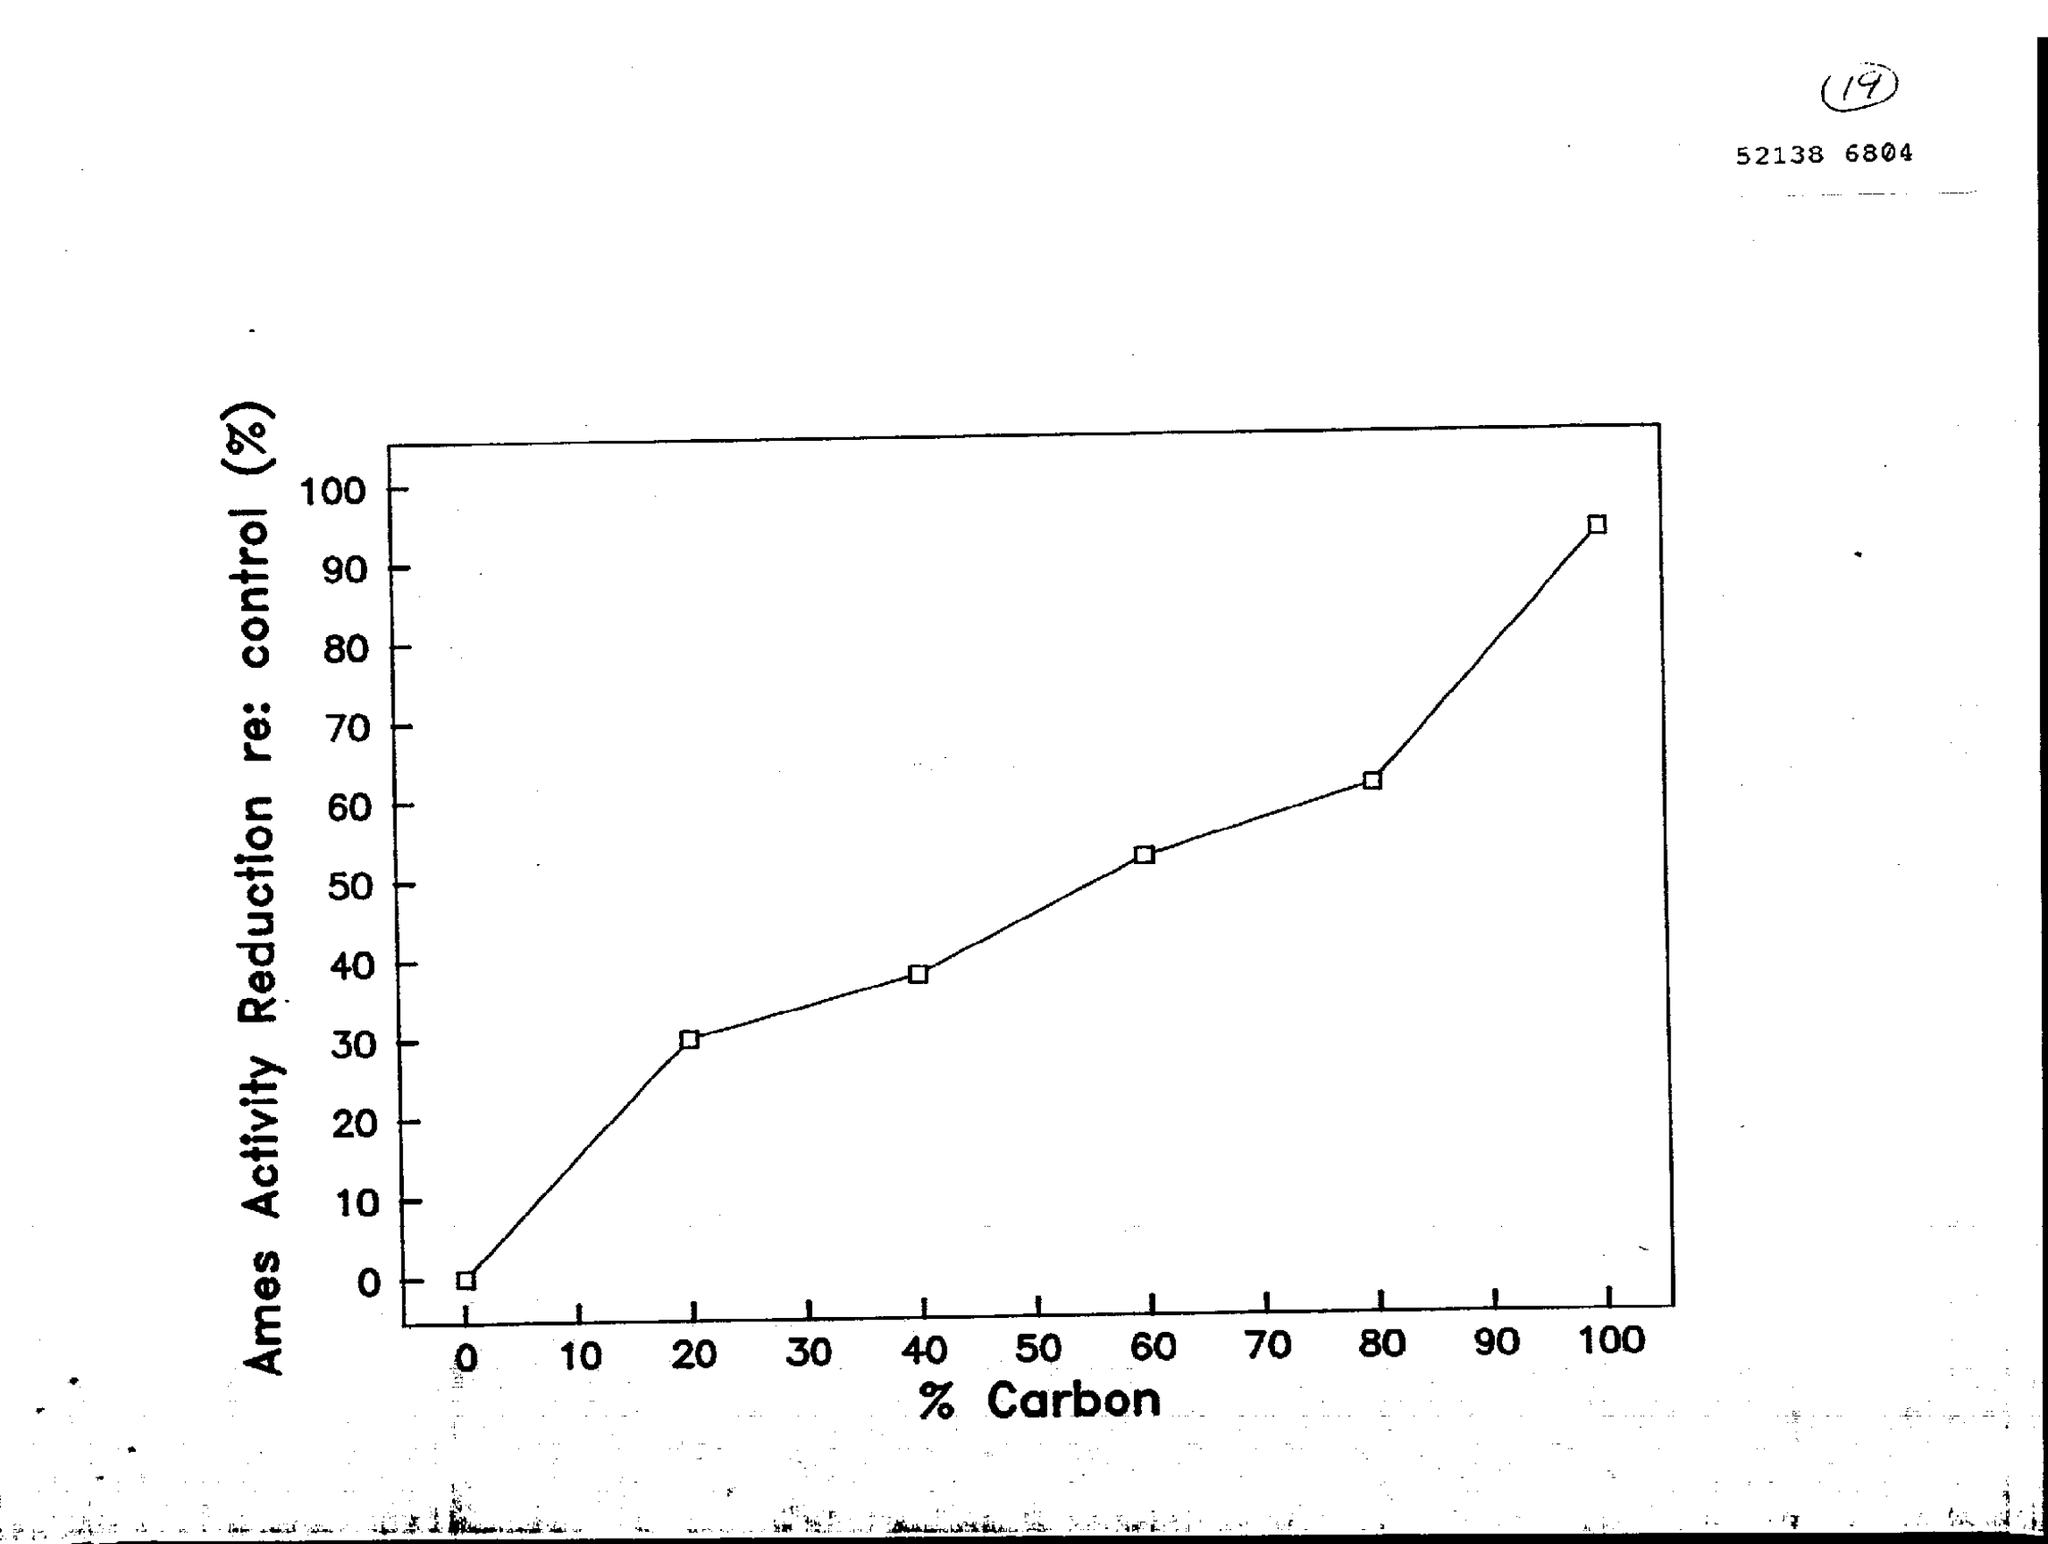Identify some key points in this picture. The Ames Activity Reduction in relation to the control is shown on the Y axis of the graph, with the percentage value represented. The variable on the x-axis of the graph represents the percentage of carbon. 